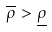<formula> <loc_0><loc_0><loc_500><loc_500>\overline { \rho } > \underline { \rho }</formula> 